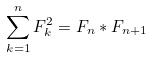Convert formula to latex. <formula><loc_0><loc_0><loc_500><loc_500>\sum _ { k = 1 } ^ { n } F _ { k } ^ { 2 } = F _ { n } * F _ { n + 1 }</formula> 